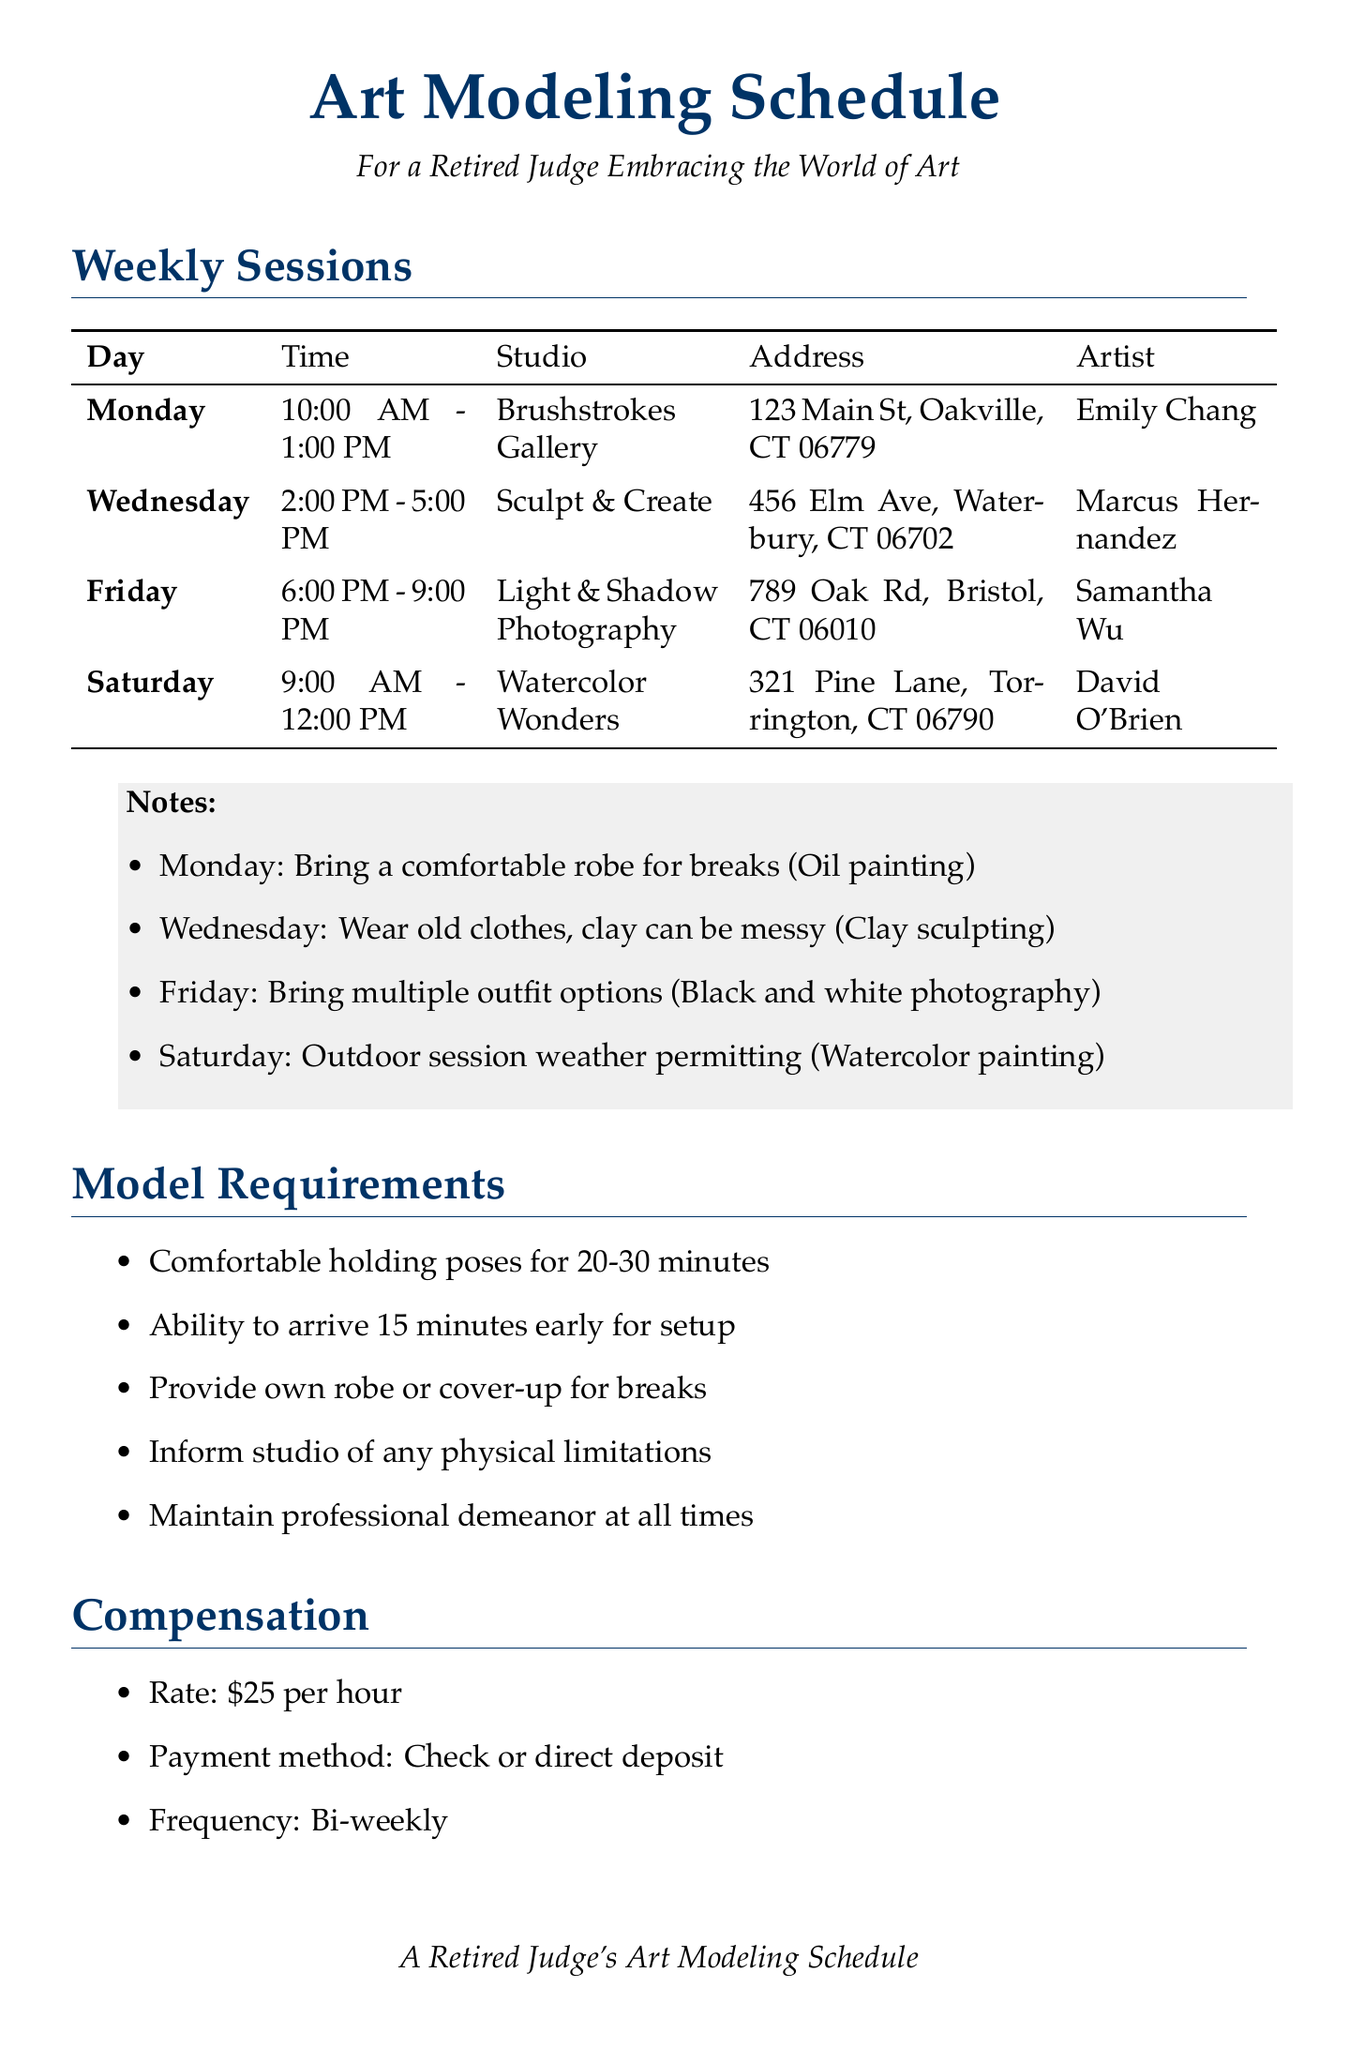What day is the watercolor painting session? The watercolor painting session is scheduled for Saturday according to the document.
Answer: Saturday Who is the artist for the clay sculpting session? The artist for the clay sculpting session on Wednesday is Marcus Hernandez.
Answer: Marcus Hernandez What is the time for the photography session? The photography session runs from 6:00 PM to 9:00 PM on Friday.
Answer: 6:00 PM - 9:00 PM How many minutes should a model be comfortable holding poses? The document states models should be comfortable holding poses for 20-30 minutes.
Answer: 20-30 minutes What is the cancellation notice required for late cancellations? The cancellation policy mentions a notice of 24 hours is required.
Answer: 24 hours How often are models compensated? The compensation frequency for models is bi-weekly as per the document.
Answer: Bi-weekly What is the address of the Brushstrokes Gallery? The address for Brushstrokes Gallery is listed as 123 Main St, Oakville, CT 06779.
Answer: 123 Main St, Oakville, CT 06779 What do models need to bring for the oil painting session? Models should bring a comfortable robe for breaks during the oil painting session.
Answer: A comfortable robe When is the Law and Art Symposium scheduled? The Law and Art Symposium is scheduled for November 5, 2023.
Answer: November 5, 2023 What is the late cancellation fee? The document states that the late cancellation fee is $20.
Answer: $20 